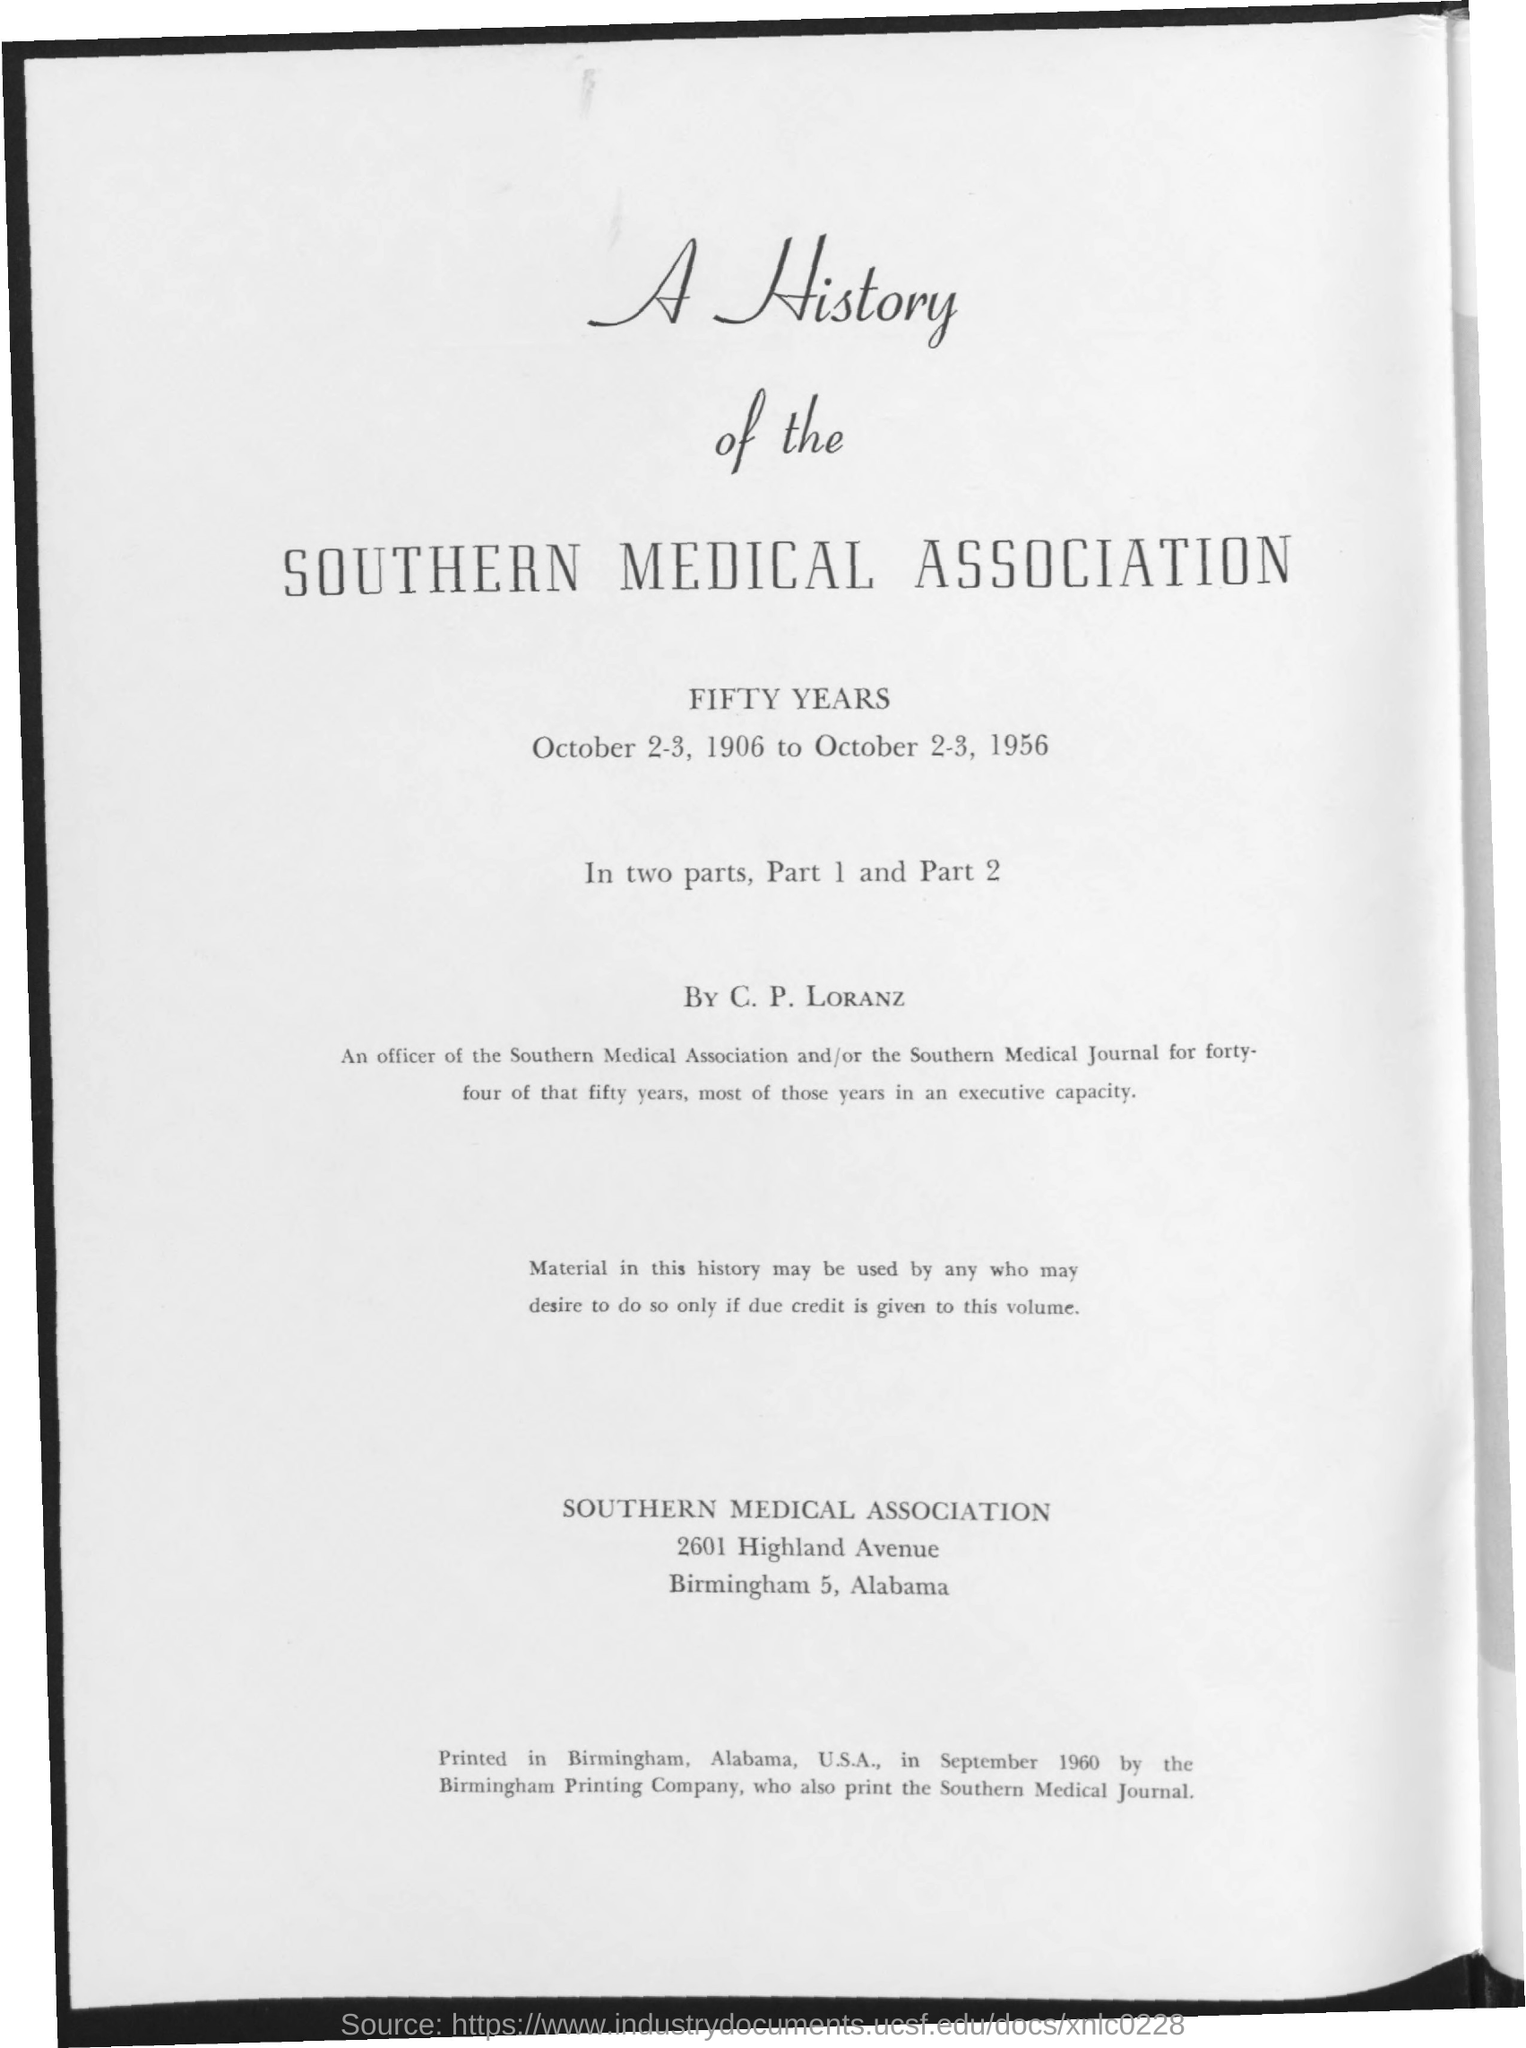Who is A History of the Southern Medical Association by?
Keep it short and to the point. C. P. Loranz. 